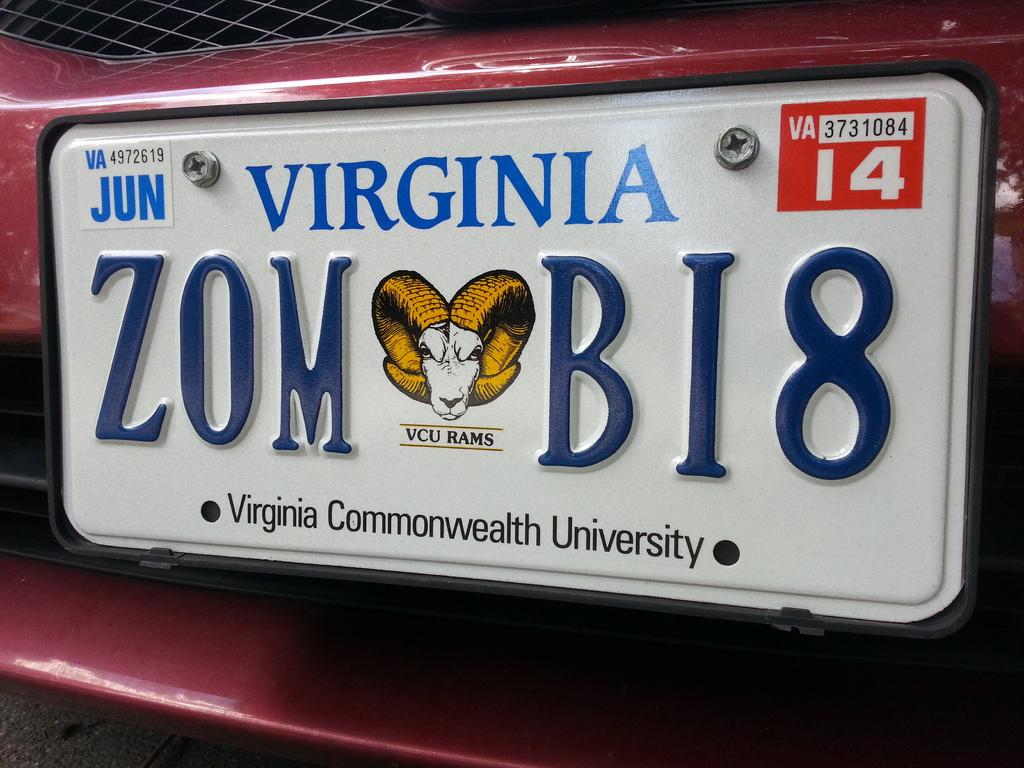Is this vanity license plate trying to spell out something?
Offer a very short reply. Yes. What state is on the plate?
Keep it short and to the point. Virginia. 